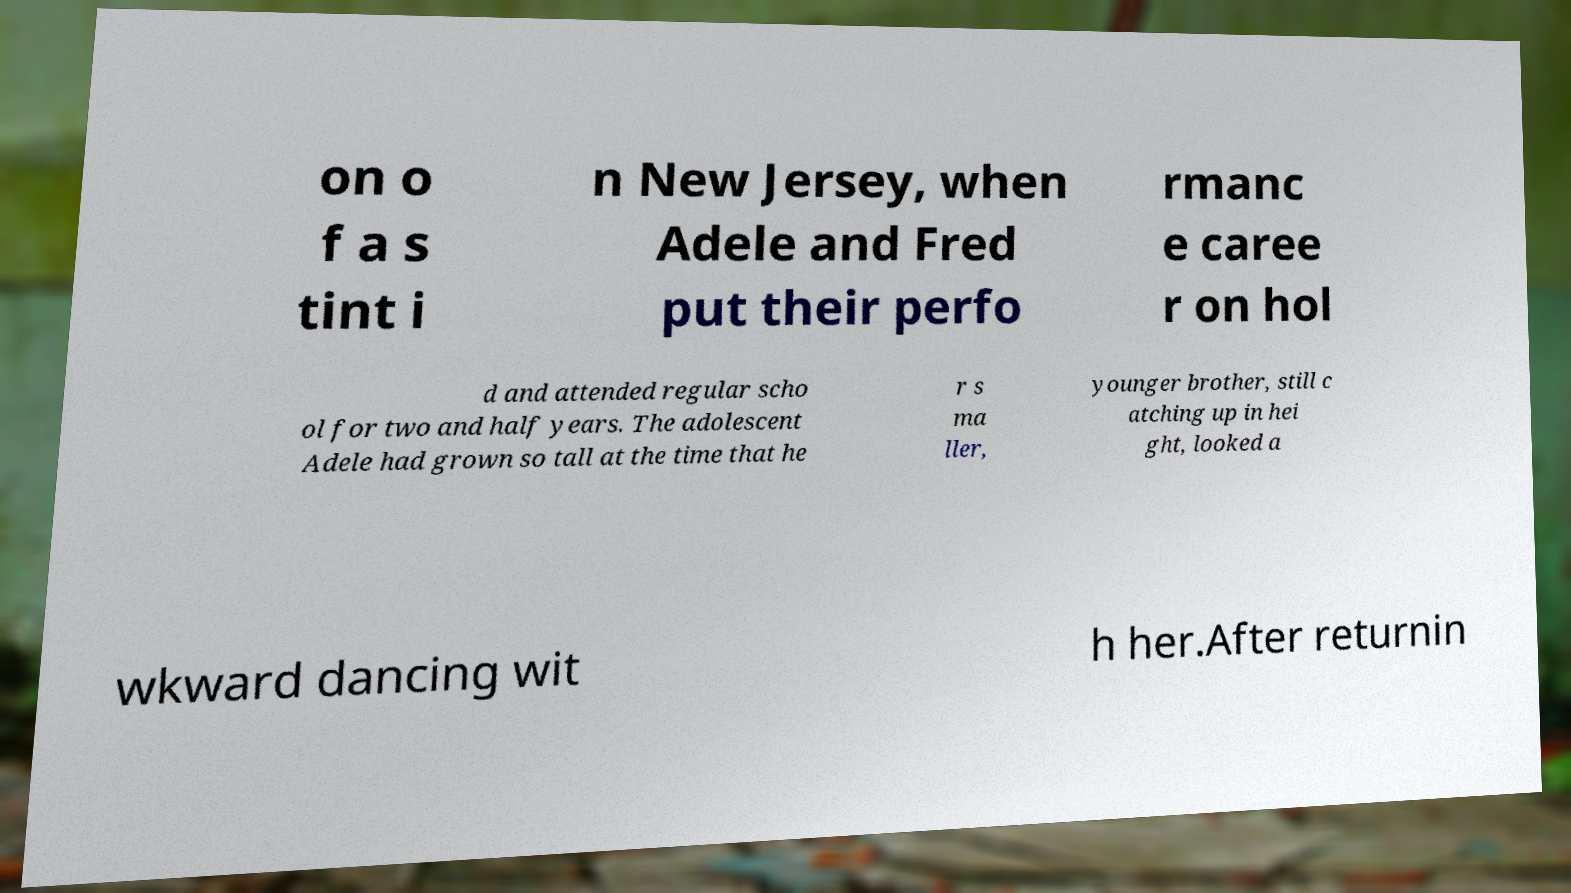There's text embedded in this image that I need extracted. Can you transcribe it verbatim? on o f a s tint i n New Jersey, when Adele and Fred put their perfo rmanc e caree r on hol d and attended regular scho ol for two and half years. The adolescent Adele had grown so tall at the time that he r s ma ller, younger brother, still c atching up in hei ght, looked a wkward dancing wit h her.After returnin 